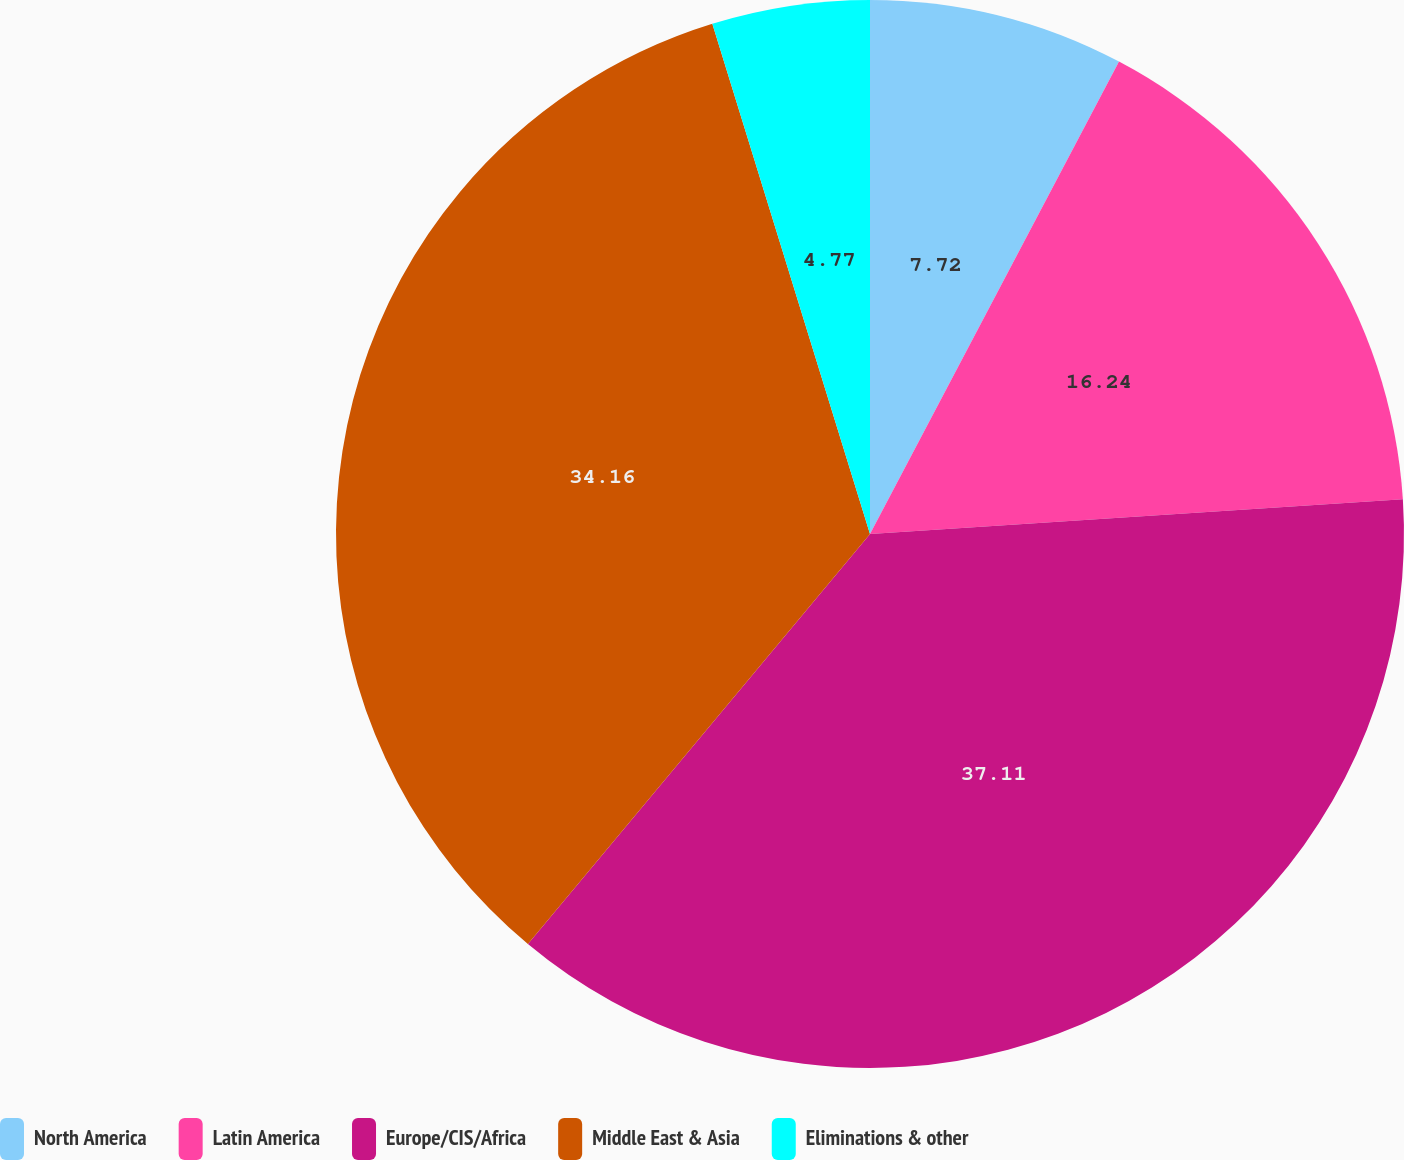Convert chart. <chart><loc_0><loc_0><loc_500><loc_500><pie_chart><fcel>North America<fcel>Latin America<fcel>Europe/CIS/Africa<fcel>Middle East & Asia<fcel>Eliminations & other<nl><fcel>7.72%<fcel>16.24%<fcel>37.1%<fcel>34.16%<fcel>4.77%<nl></chart> 